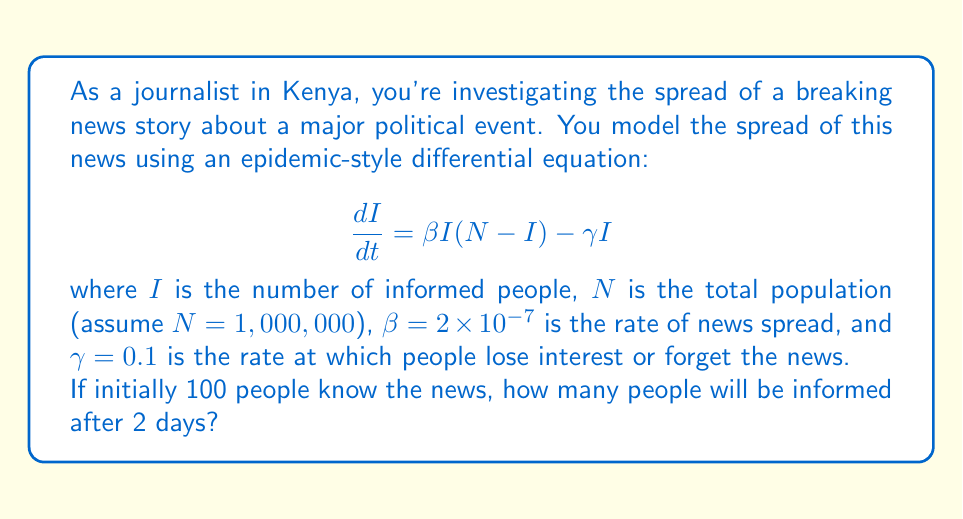Solve this math problem. To solve this problem, we need to use numerical methods as the differential equation is nonlinear. We'll use the Euler method with a small time step.

1) First, let's set up our initial conditions and parameters:
   $I(0) = 100$
   $N = 1,000,000$
   $\beta = 2 \times 10^{-7}$
   $\gamma = 0.1$
   $t_{final} = 2$ days

2) We'll use a time step of $\Delta t = 0.1$ days, so we need 20 steps to reach 2 days.

3) The Euler method is given by:
   $I_{n+1} = I_n + \Delta t \cdot f(I_n)$
   where $f(I) = \beta I(N-I) - \gamma I$

4) Let's implement this in a step-by-step calculation:

   $I_0 = 100$
   $I_1 = 100 + 0.1 \cdot (2 \times 10^{-7} \cdot 100 \cdot (1000000 - 100) - 0.1 \cdot 100) = 109.98$
   $I_2 = 109.98 + 0.1 \cdot (2 \times 10^{-7} \cdot 109.98 \cdot (1000000 - 109.98) - 0.1 \cdot 109.98) = 120.94$
   ...

5) Continuing this process for 20 steps, we get:
   $I_{20} \approx 497.32$

6) Therefore, after 2 days, approximately 497 people will be informed about the news.
Answer: Approximately 497 people will be informed about the news after 2 days. 